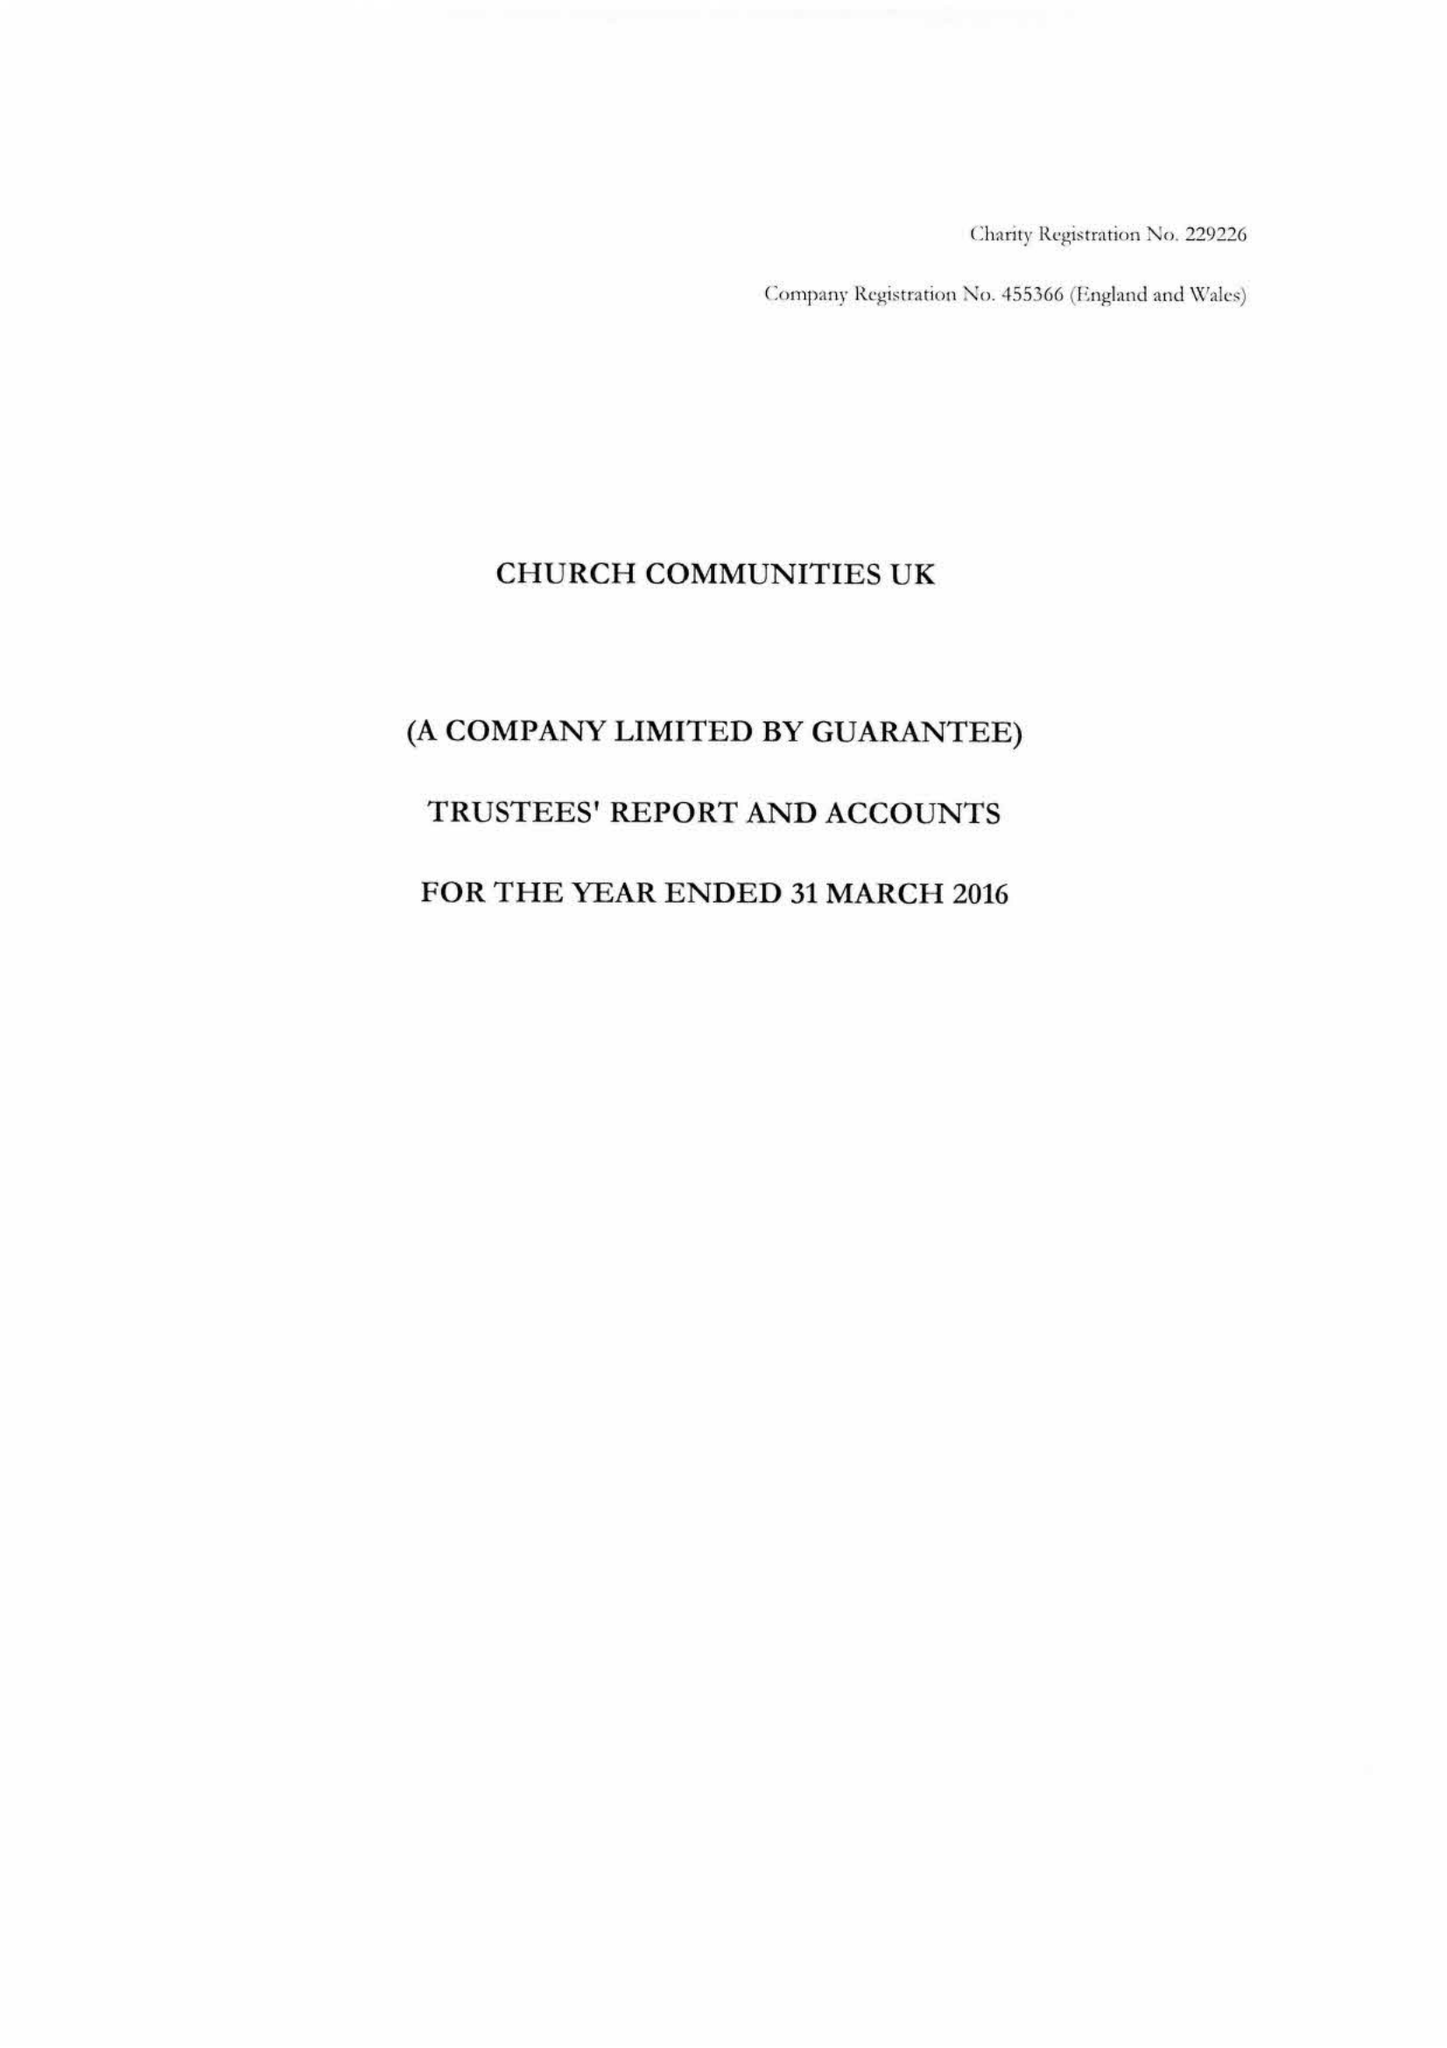What is the value for the charity_name?
Answer the question using a single word or phrase. Church Communities Uk 